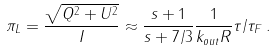<formula> <loc_0><loc_0><loc_500><loc_500>\pi _ { L } = \frac { \sqrt { Q ^ { 2 } + U ^ { 2 } } } { I } \approx \frac { s + 1 } { s + 7 / 3 } \frac { 1 } { k _ { o u t } R } \tau / \tau _ { F } \, .</formula> 